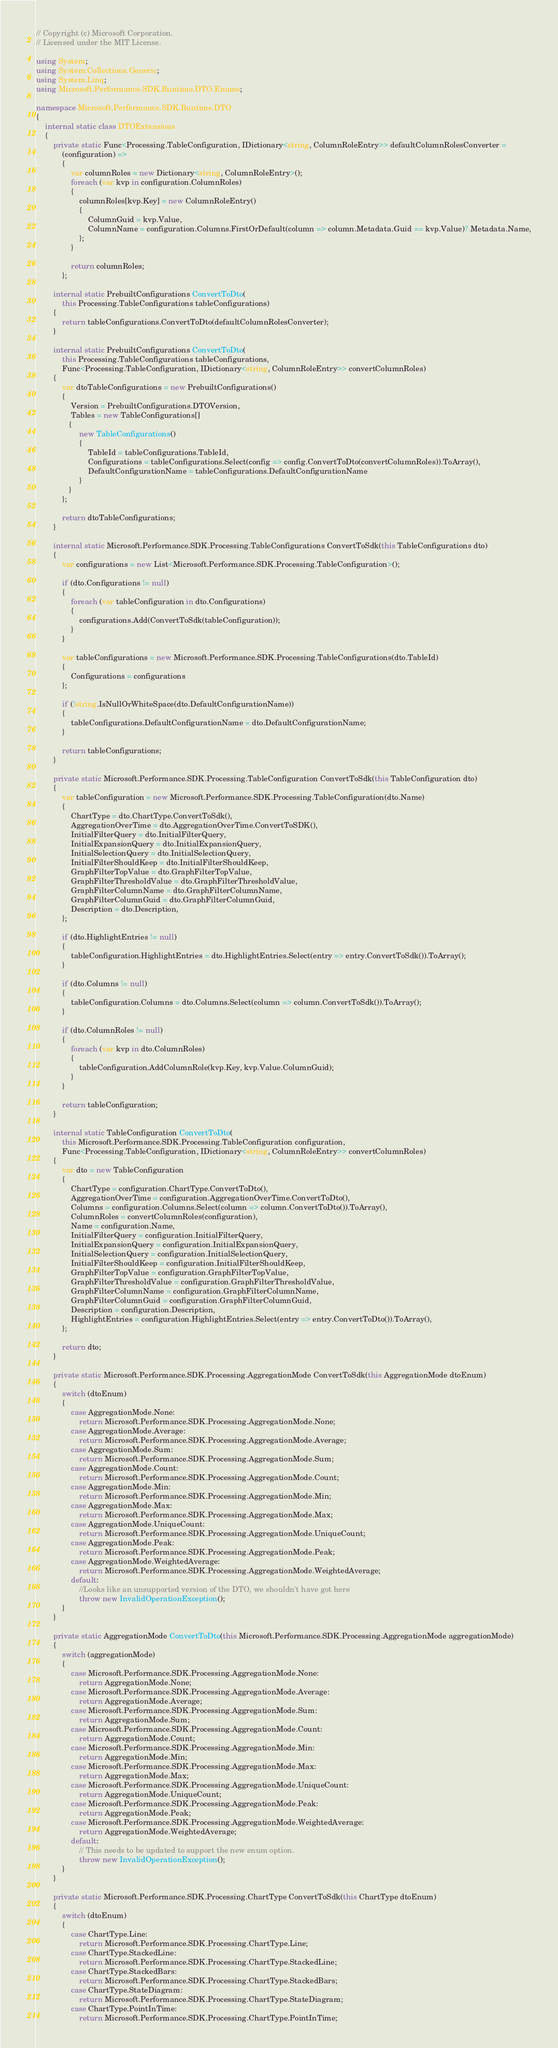Convert code to text. <code><loc_0><loc_0><loc_500><loc_500><_C#_>// Copyright (c) Microsoft Corporation.
// Licensed under the MIT License.

using System;
using System.Collections.Generic;
using System.Linq;
using Microsoft.Performance.SDK.Runtime.DTO.Enums;

namespace Microsoft.Performance.SDK.Runtime.DTO
{
    internal static class DTOExtensions
    {
        private static Func<Processing.TableConfiguration, IDictionary<string, ColumnRoleEntry>> defaultColumnRolesConverter = 
            (configuration) =>
            {
                var columnRoles = new Dictionary<string, ColumnRoleEntry>();
                foreach (var kvp in configuration.ColumnRoles)
                {
                    columnRoles[kvp.Key] = new ColumnRoleEntry()
                    {
                        ColumnGuid = kvp.Value,
                        ColumnName = configuration.Columns.FirstOrDefault(column => column.Metadata.Guid == kvp.Value)?.Metadata.Name,
                    };
                }

                return columnRoles;
            };

        internal static PrebuiltConfigurations ConvertToDto(
            this Processing.TableConfigurations tableConfigurations)
        {
            return tableConfigurations.ConvertToDto(defaultColumnRolesConverter);
        }

        internal static PrebuiltConfigurations ConvertToDto(
            this Processing.TableConfigurations tableConfigurations,
            Func<Processing.TableConfiguration, IDictionary<string, ColumnRoleEntry>> convertColumnRoles)
        {
            var dtoTableConfigurations = new PrebuiltConfigurations()
            {
                Version = PrebuiltConfigurations.DTOVersion,
                Tables = new TableConfigurations[]
               {
                    new TableConfigurations()
                    {
                        TableId = tableConfigurations.TableId,
                        Configurations = tableConfigurations.Select(config => config.ConvertToDto(convertColumnRoles)).ToArray(),
                        DefaultConfigurationName = tableConfigurations.DefaultConfigurationName
                    }
               }
            };

            return dtoTableConfigurations;
        }

        internal static Microsoft.Performance.SDK.Processing.TableConfigurations ConvertToSdk(this TableConfigurations dto)
        {
            var configurations = new List<Microsoft.Performance.SDK.Processing.TableConfiguration>();

            if (dto.Configurations != null)
            {
                foreach (var tableConfiguration in dto.Configurations)
                {
                    configurations.Add(ConvertToSdk(tableConfiguration));
                }
            }

            var tableConfigurations = new Microsoft.Performance.SDK.Processing.TableConfigurations(dto.TableId)
            {
                Configurations = configurations
            };

            if (!string.IsNullOrWhiteSpace(dto.DefaultConfigurationName))
            {
                tableConfigurations.DefaultConfigurationName = dto.DefaultConfigurationName;
            }

            return tableConfigurations;
        }

        private static Microsoft.Performance.SDK.Processing.TableConfiguration ConvertToSdk(this TableConfiguration dto)
        {
            var tableConfiguration = new Microsoft.Performance.SDK.Processing.TableConfiguration(dto.Name)
            {
                ChartType = dto.ChartType.ConvertToSdk(),
                AggregationOverTime = dto.AggregationOverTime.ConvertToSDK(),
                InitialFilterQuery = dto.InitialFilterQuery,
                InitialExpansionQuery = dto.InitialExpansionQuery,
                InitialSelectionQuery = dto.InitialSelectionQuery,
                InitialFilterShouldKeep = dto.InitialFilterShouldKeep,
                GraphFilterTopValue = dto.GraphFilterTopValue,
                GraphFilterThresholdValue = dto.GraphFilterThresholdValue,
                GraphFilterColumnName = dto.GraphFilterColumnName,
                GraphFilterColumnGuid = dto.GraphFilterColumnGuid,
                Description = dto.Description,
            };

            if (dto.HighlightEntries != null)
            {
                tableConfiguration.HighlightEntries = dto.HighlightEntries.Select(entry => entry.ConvertToSdk()).ToArray();
            }

            if (dto.Columns != null)
            {
                tableConfiguration.Columns = dto.Columns.Select(column => column.ConvertToSdk()).ToArray();
            }

            if (dto.ColumnRoles != null)
            {
                foreach (var kvp in dto.ColumnRoles)
                {
                    tableConfiguration.AddColumnRole(kvp.Key, kvp.Value.ColumnGuid);
                }
            }

            return tableConfiguration;
        }

        internal static TableConfiguration ConvertToDto(
            this Microsoft.Performance.SDK.Processing.TableConfiguration configuration,
            Func<Processing.TableConfiguration, IDictionary<string, ColumnRoleEntry>> convertColumnRoles)
        {
            var dto = new TableConfiguration
            {
                ChartType = configuration.ChartType.ConvertToDto(),
                AggregationOverTime = configuration.AggregationOverTime.ConvertToDto(),
                Columns = configuration.Columns.Select(column => column.ConvertToDto()).ToArray(),
                ColumnRoles = convertColumnRoles(configuration),
                Name = configuration.Name,
                InitialFilterQuery = configuration.InitialFilterQuery,
                InitialExpansionQuery = configuration.InitialExpansionQuery,
                InitialSelectionQuery = configuration.InitialSelectionQuery,
                InitialFilterShouldKeep = configuration.InitialFilterShouldKeep,
                GraphFilterTopValue = configuration.GraphFilterTopValue,
                GraphFilterThresholdValue = configuration.GraphFilterThresholdValue,
                GraphFilterColumnName = configuration.GraphFilterColumnName,
                GraphFilterColumnGuid = configuration.GraphFilterColumnGuid,
                Description = configuration.Description,
                HighlightEntries = configuration.HighlightEntries.Select(entry => entry.ConvertToDto()).ToArray(),
            };

            return dto;
        }

        private static Microsoft.Performance.SDK.Processing.AggregationMode ConvertToSdk(this AggregationMode dtoEnum)
        {
            switch (dtoEnum)
            {
                case AggregationMode.None:
                    return Microsoft.Performance.SDK.Processing.AggregationMode.None;
                case AggregationMode.Average:
                    return Microsoft.Performance.SDK.Processing.AggregationMode.Average;
                case AggregationMode.Sum:
                    return Microsoft.Performance.SDK.Processing.AggregationMode.Sum;
                case AggregationMode.Count:
                    return Microsoft.Performance.SDK.Processing.AggregationMode.Count;
                case AggregationMode.Min:
                    return Microsoft.Performance.SDK.Processing.AggregationMode.Min;
                case AggregationMode.Max:
                    return Microsoft.Performance.SDK.Processing.AggregationMode.Max;
                case AggregationMode.UniqueCount:
                    return Microsoft.Performance.SDK.Processing.AggregationMode.UniqueCount;
                case AggregationMode.Peak:
                    return Microsoft.Performance.SDK.Processing.AggregationMode.Peak;
                case AggregationMode.WeightedAverage:
                    return Microsoft.Performance.SDK.Processing.AggregationMode.WeightedAverage;
                default:
                    //Looks like an unsupported version of the DTO, we shouldn't have got here
                    throw new InvalidOperationException();
            }
        }

        private static AggregationMode ConvertToDto(this Microsoft.Performance.SDK.Processing.AggregationMode aggregationMode)
        {
            switch (aggregationMode)
            {
                case Microsoft.Performance.SDK.Processing.AggregationMode.None:
                    return AggregationMode.None;
                case Microsoft.Performance.SDK.Processing.AggregationMode.Average:
                    return AggregationMode.Average;
                case Microsoft.Performance.SDK.Processing.AggregationMode.Sum:
                    return AggregationMode.Sum;
                case Microsoft.Performance.SDK.Processing.AggregationMode.Count:
                    return AggregationMode.Count;
                case Microsoft.Performance.SDK.Processing.AggregationMode.Min:
                    return AggregationMode.Min;
                case Microsoft.Performance.SDK.Processing.AggregationMode.Max:
                    return AggregationMode.Max;
                case Microsoft.Performance.SDK.Processing.AggregationMode.UniqueCount:
                    return AggregationMode.UniqueCount;
                case Microsoft.Performance.SDK.Processing.AggregationMode.Peak:
                    return AggregationMode.Peak;
                case Microsoft.Performance.SDK.Processing.AggregationMode.WeightedAverage:
                    return AggregationMode.WeightedAverage;
                default:
                    // This needs to be updated to support the new enum option.
                    throw new InvalidOperationException();
            }
        }

        private static Microsoft.Performance.SDK.Processing.ChartType ConvertToSdk(this ChartType dtoEnum)
        {
            switch (dtoEnum)
            {
                case ChartType.Line:
                    return Microsoft.Performance.SDK.Processing.ChartType.Line;
                case ChartType.StackedLine:
                    return Microsoft.Performance.SDK.Processing.ChartType.StackedLine;
                case ChartType.StackedBars:
                    return Microsoft.Performance.SDK.Processing.ChartType.StackedBars;
                case ChartType.StateDiagram:
                    return Microsoft.Performance.SDK.Processing.ChartType.StateDiagram;
                case ChartType.PointInTime:
                    return Microsoft.Performance.SDK.Processing.ChartType.PointInTime;</code> 